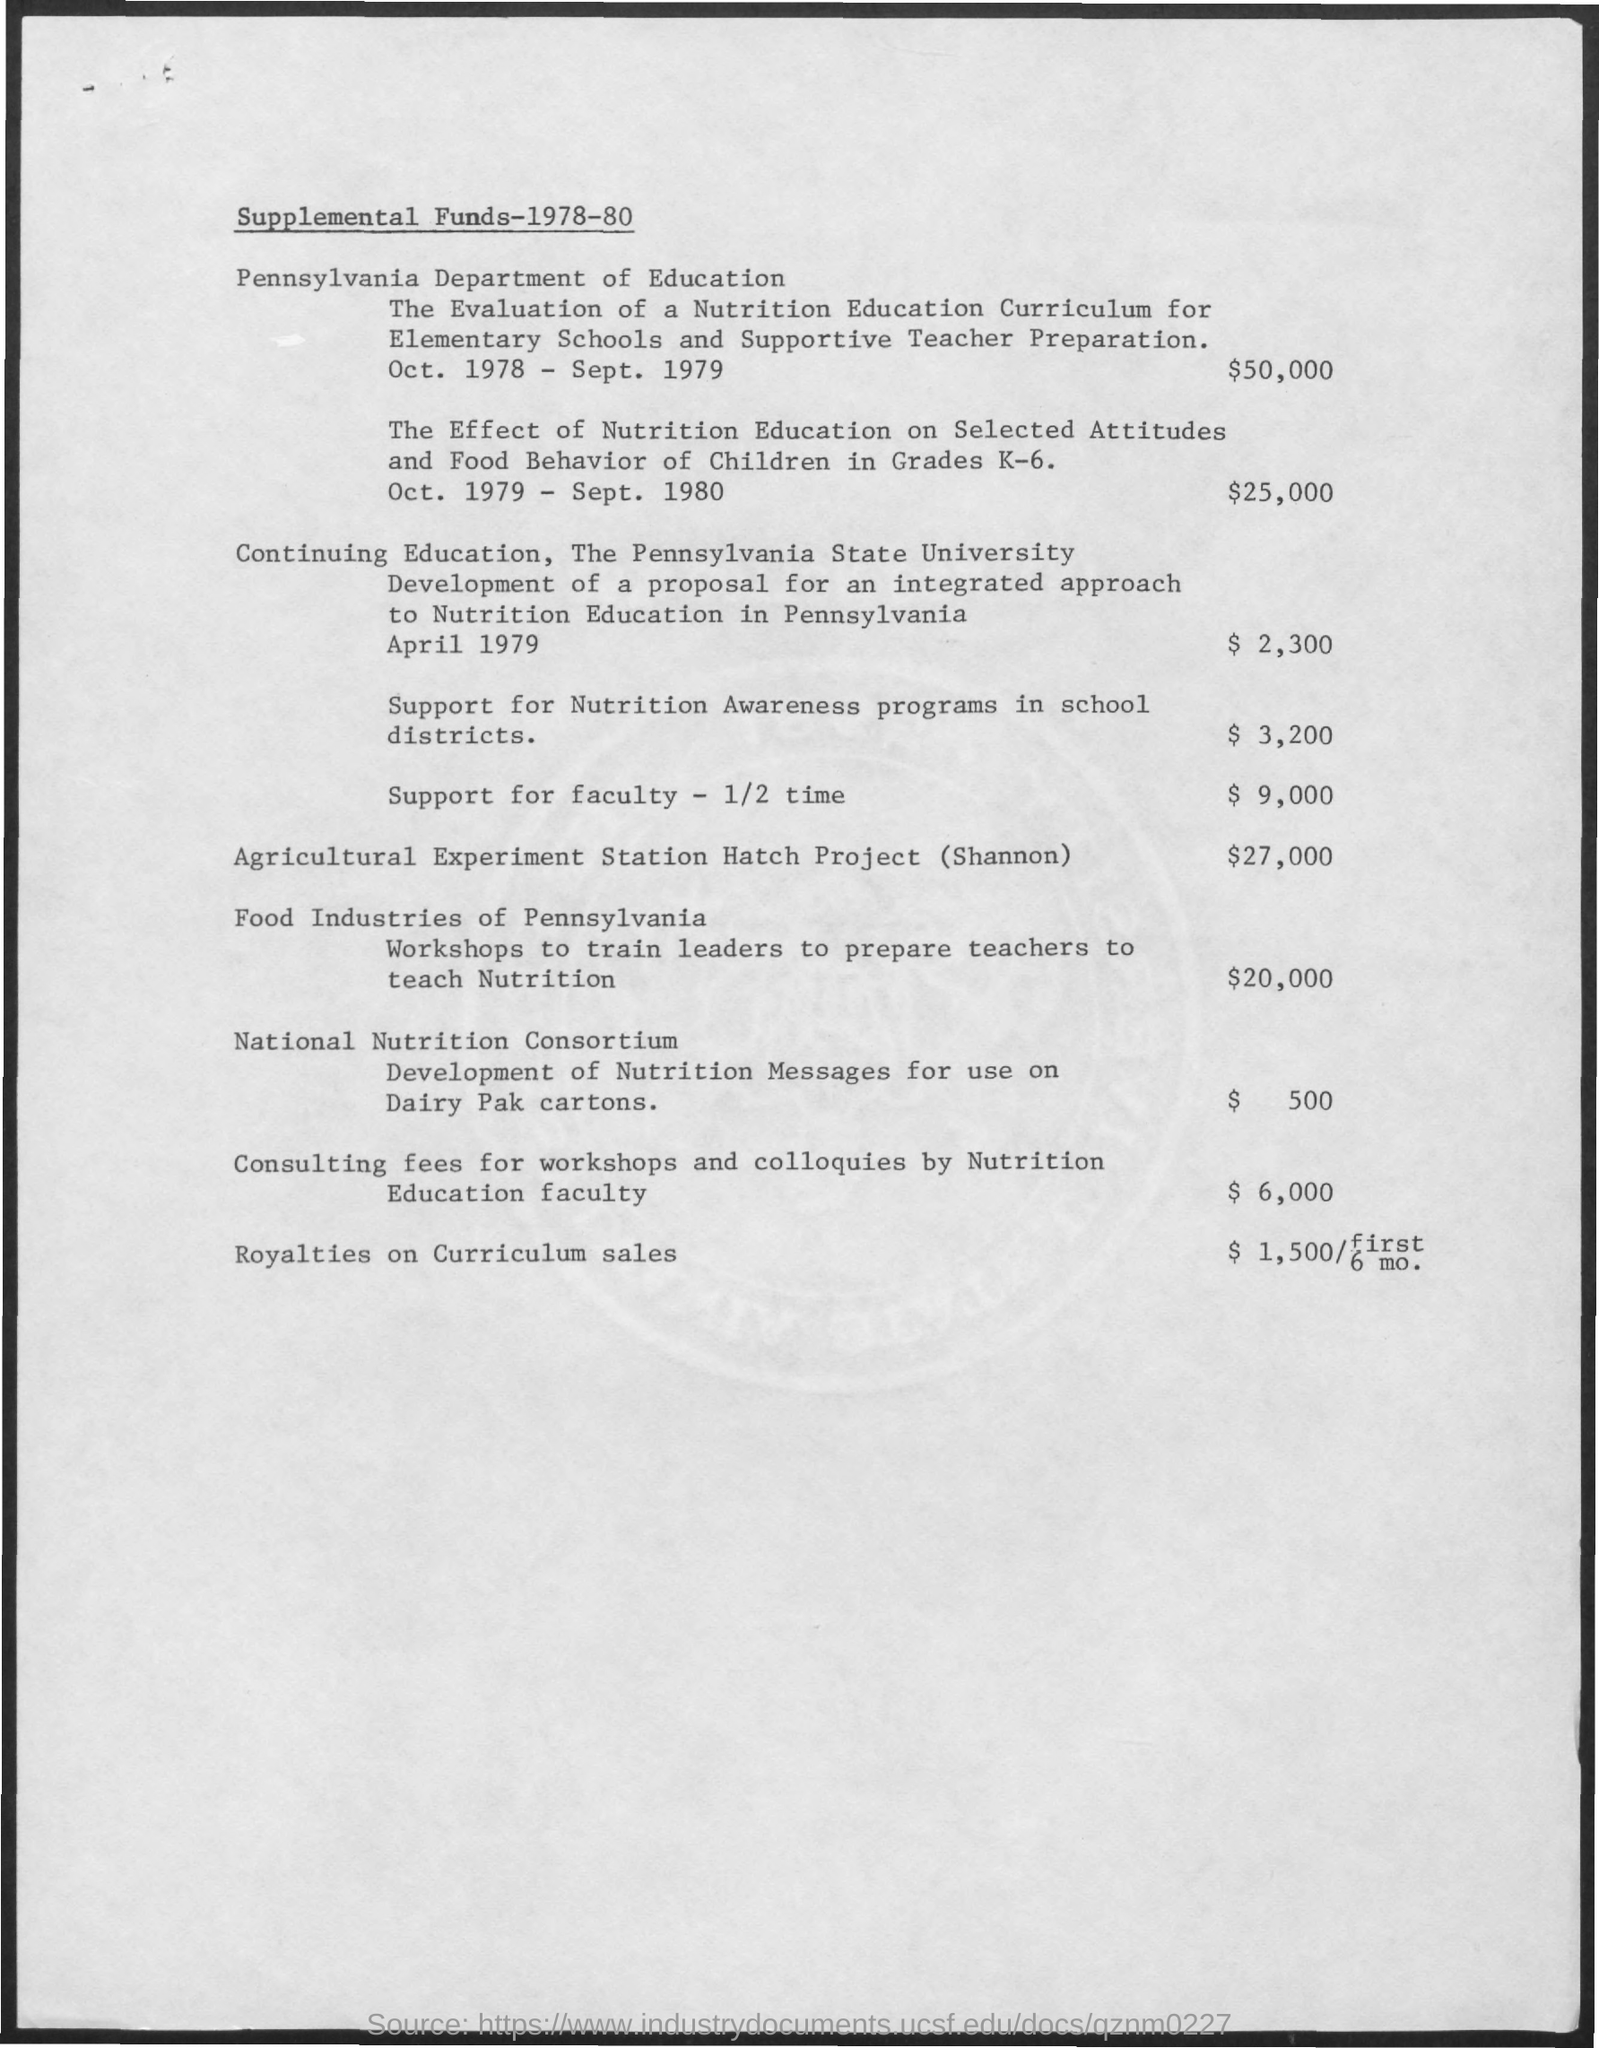Specify some key components in this picture. The funding for faculty support is $9,000. The amount of fund designated for the Agricultural Experiment Station Hatch Project (Shannon) is $27,000. The amount of funding for support of nutrition awareness programs in school districts is $3,200. 